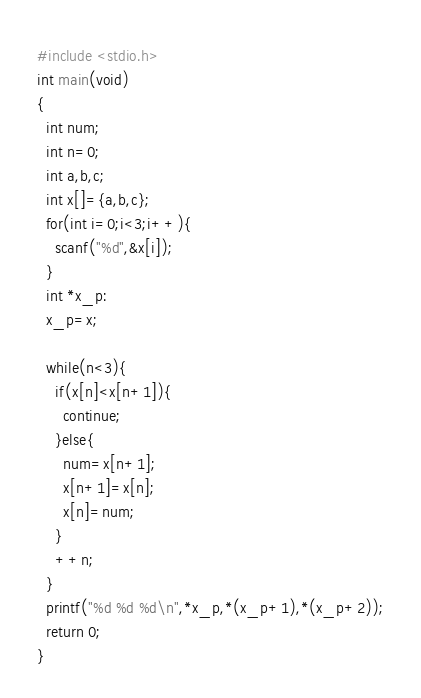<code> <loc_0><loc_0><loc_500><loc_500><_C_>#include <stdio.h>
int main(void)
{
  int num;
  int n=0;
  int a,b,c;
  int x[]={a,b,c};
  for(int i=0;i<3;i++){
    scanf("%d",&x[i]);
  }
  int *x_p:
  x_p=x;
  
  while(n<3){
    if(x[n]<x[n+1]){
      continue;
    }else{
      num=x[n+1];
      x[n+1]=x[n];
      x[n]=num;
    }
    ++n;
  }
  printf("%d %d %d\n",*x_p,*(x_p+1),*(x_p+2));
  return 0;
}
</code> 